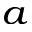Convert formula to latex. <formula><loc_0><loc_0><loc_500><loc_500>^ { a }</formula> 